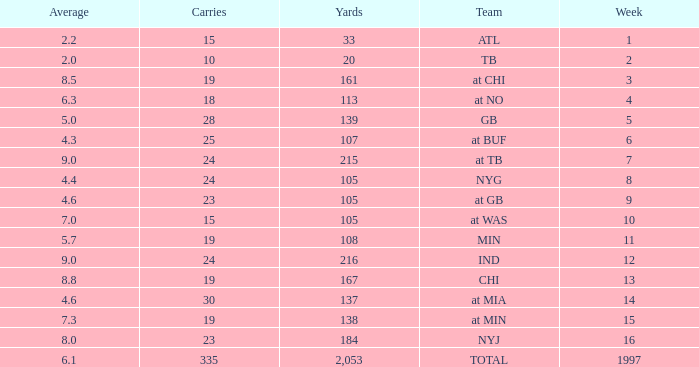Which Team has 19 Carries, and a Week larger than 13? At min. 